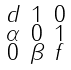Convert formula to latex. <formula><loc_0><loc_0><loc_500><loc_500>\begin{smallmatrix} d & 1 & 0 \\ \alpha & 0 & 1 \\ 0 & \beta & f \\ \end{smallmatrix}</formula> 